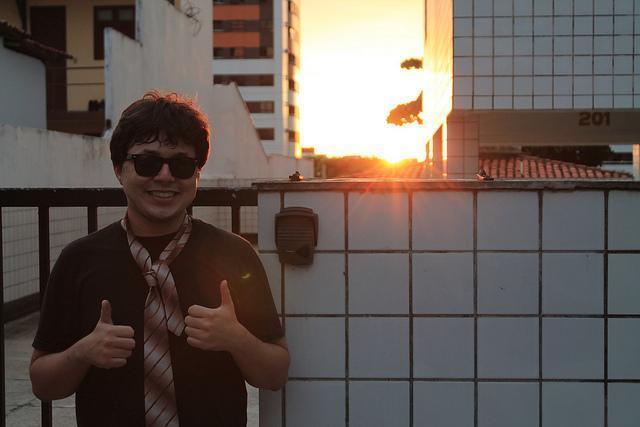How many cats are there?
Give a very brief answer. 0. 